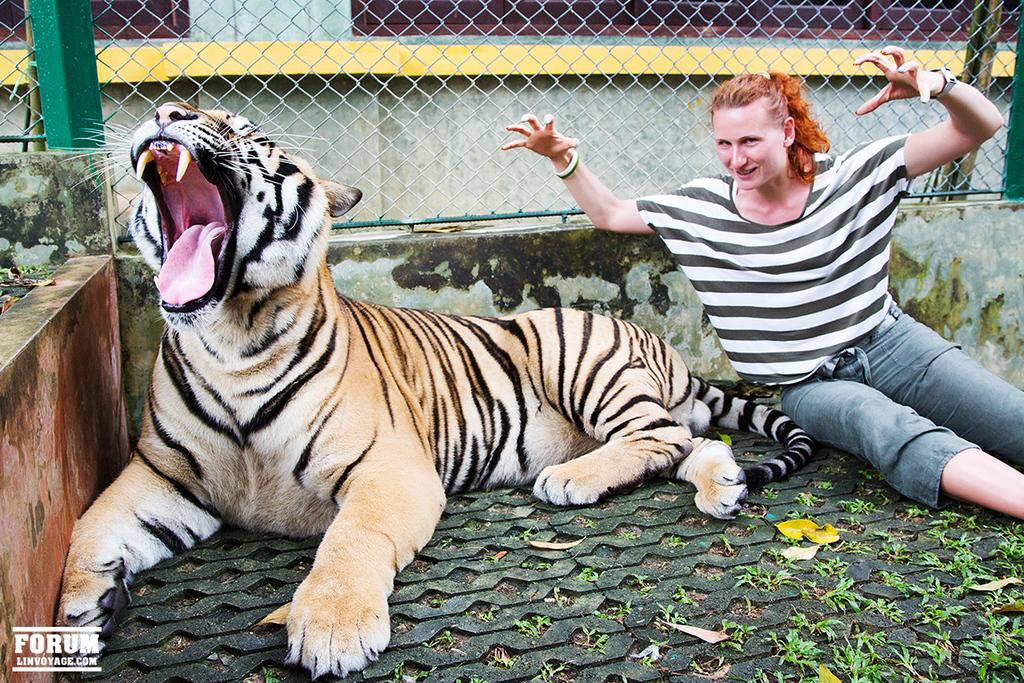What type of animal is in the image? There is an animal in the image, but its specific type cannot be determined from the provided facts. Can you describe the color of the animal in the image? The animal is in brown and cream color. What else is present in the image besides the animal? There is a person sitting in the image. What can be seen in the background of the image? There is railing visible in the background of the image. What type of tooth is visible in the image? There is no tooth visible in the image. What view can be seen from the railing in the image? The provided facts do not give any information about the view from the railing, only that it is visible in the background. 